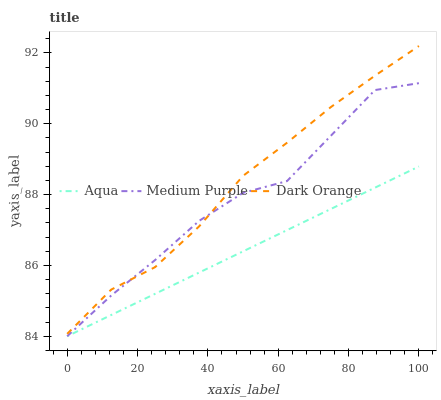Does Aqua have the minimum area under the curve?
Answer yes or no. Yes. Does Dark Orange have the maximum area under the curve?
Answer yes or no. Yes. Does Dark Orange have the minimum area under the curve?
Answer yes or no. No. Does Aqua have the maximum area under the curve?
Answer yes or no. No. Is Aqua the smoothest?
Answer yes or no. Yes. Is Medium Purple the roughest?
Answer yes or no. Yes. Is Dark Orange the smoothest?
Answer yes or no. No. Is Dark Orange the roughest?
Answer yes or no. No. Does Medium Purple have the lowest value?
Answer yes or no. Yes. Does Dark Orange have the lowest value?
Answer yes or no. No. Does Dark Orange have the highest value?
Answer yes or no. Yes. Does Aqua have the highest value?
Answer yes or no. No. Is Aqua less than Dark Orange?
Answer yes or no. Yes. Is Dark Orange greater than Aqua?
Answer yes or no. Yes. Does Medium Purple intersect Aqua?
Answer yes or no. Yes. Is Medium Purple less than Aqua?
Answer yes or no. No. Is Medium Purple greater than Aqua?
Answer yes or no. No. Does Aqua intersect Dark Orange?
Answer yes or no. No. 